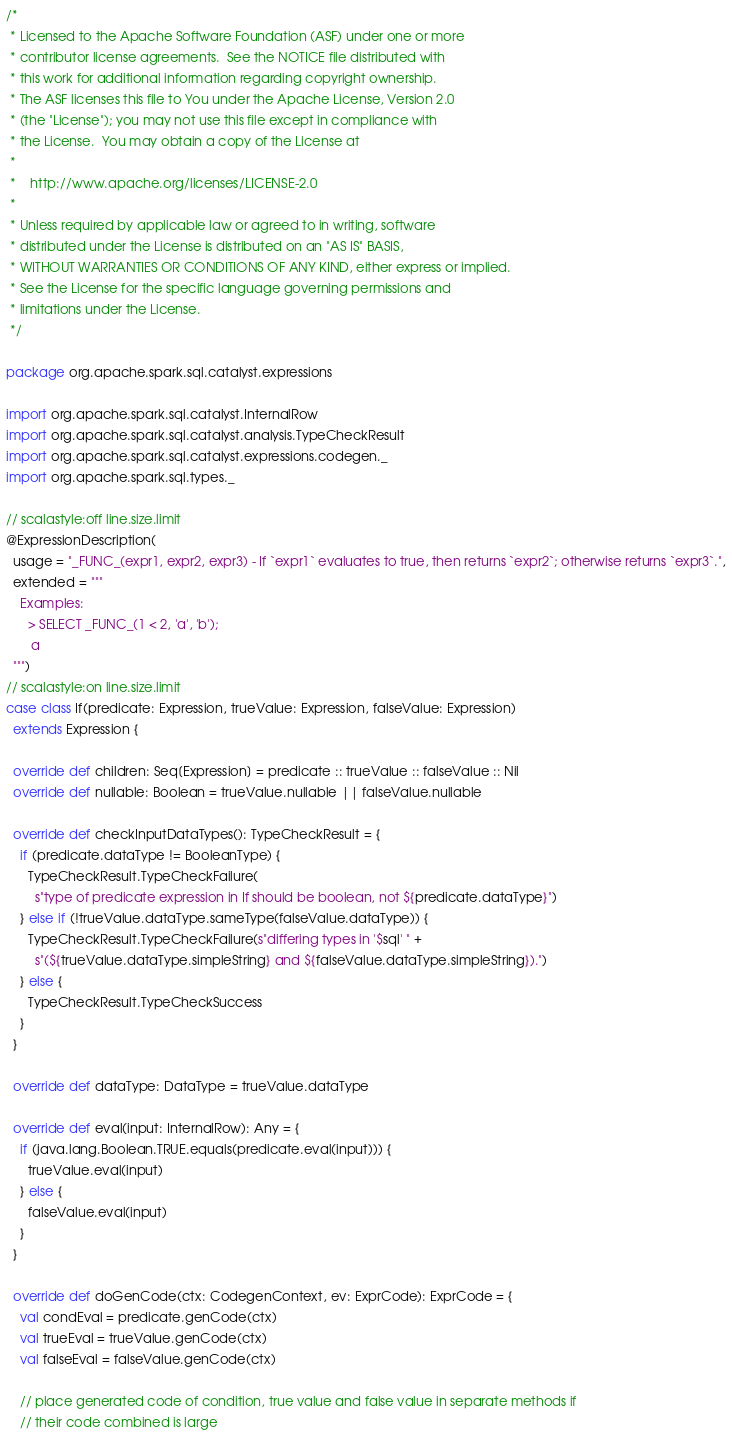Convert code to text. <code><loc_0><loc_0><loc_500><loc_500><_Scala_>/*
 * Licensed to the Apache Software Foundation (ASF) under one or more
 * contributor license agreements.  See the NOTICE file distributed with
 * this work for additional information regarding copyright ownership.
 * The ASF licenses this file to You under the Apache License, Version 2.0
 * (the "License"); you may not use this file except in compliance with
 * the License.  You may obtain a copy of the License at
 *
 *    http://www.apache.org/licenses/LICENSE-2.0
 *
 * Unless required by applicable law or agreed to in writing, software
 * distributed under the License is distributed on an "AS IS" BASIS,
 * WITHOUT WARRANTIES OR CONDITIONS OF ANY KIND, either express or implied.
 * See the License for the specific language governing permissions and
 * limitations under the License.
 */

package org.apache.spark.sql.catalyst.expressions

import org.apache.spark.sql.catalyst.InternalRow
import org.apache.spark.sql.catalyst.analysis.TypeCheckResult
import org.apache.spark.sql.catalyst.expressions.codegen._
import org.apache.spark.sql.types._

// scalastyle:off line.size.limit
@ExpressionDescription(
  usage = "_FUNC_(expr1, expr2, expr3) - If `expr1` evaluates to true, then returns `expr2`; otherwise returns `expr3`.",
  extended = """
    Examples:
      > SELECT _FUNC_(1 < 2, 'a', 'b');
       a
  """)
// scalastyle:on line.size.limit
case class If(predicate: Expression, trueValue: Expression, falseValue: Expression)
  extends Expression {

  override def children: Seq[Expression] = predicate :: trueValue :: falseValue :: Nil
  override def nullable: Boolean = trueValue.nullable || falseValue.nullable

  override def checkInputDataTypes(): TypeCheckResult = {
    if (predicate.dataType != BooleanType) {
      TypeCheckResult.TypeCheckFailure(
        s"type of predicate expression in If should be boolean, not ${predicate.dataType}")
    } else if (!trueValue.dataType.sameType(falseValue.dataType)) {
      TypeCheckResult.TypeCheckFailure(s"differing types in '$sql' " +
        s"(${trueValue.dataType.simpleString} and ${falseValue.dataType.simpleString}).")
    } else {
      TypeCheckResult.TypeCheckSuccess
    }
  }

  override def dataType: DataType = trueValue.dataType

  override def eval(input: InternalRow): Any = {
    if (java.lang.Boolean.TRUE.equals(predicate.eval(input))) {
      trueValue.eval(input)
    } else {
      falseValue.eval(input)
    }
  }

  override def doGenCode(ctx: CodegenContext, ev: ExprCode): ExprCode = {
    val condEval = predicate.genCode(ctx)
    val trueEval = trueValue.genCode(ctx)
    val falseEval = falseValue.genCode(ctx)

    // place generated code of condition, true value and false value in separate methods if
    // their code combined is large</code> 